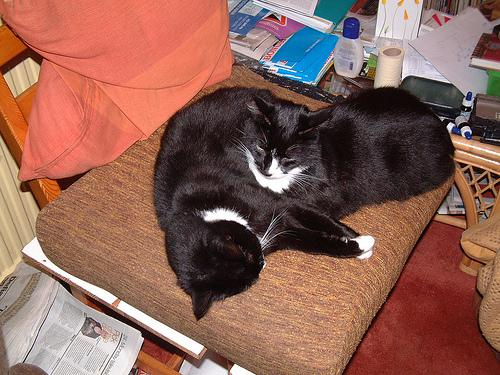Question: how many rolls of toilet paper can be seen?
Choices:
A. Five.
B. One.
C. Zero.
D. Three.
Answer with the letter. Answer: B Question: what kind of animals are on the chair?
Choices:
A. Dogs.
B. Cats.
C. Rabbits.
D. Hampsters.
Answer with the letter. Answer: B Question: how many cats are there?
Choices:
A. Five.
B. Zero.
C. Three.
D. Two.
Answer with the letter. Answer: D Question: where are the cats?
Choices:
A. On a chair.
B. On a sofa.
C. On a loveseat.
D. On a bed.
Answer with the letter. Answer: A 